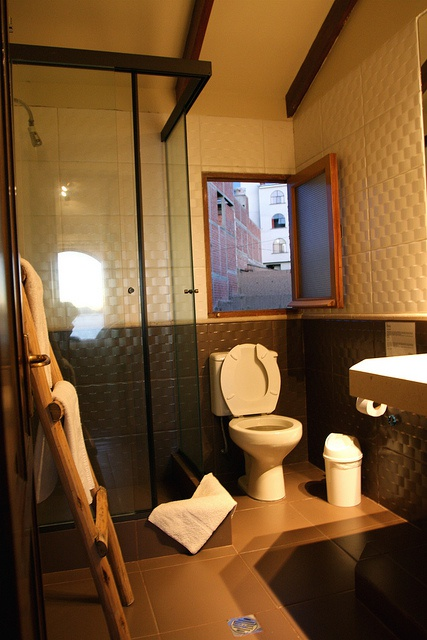Describe the objects in this image and their specific colors. I can see toilet in black, tan, olive, and maroon tones and sink in black, maroon, white, and brown tones in this image. 